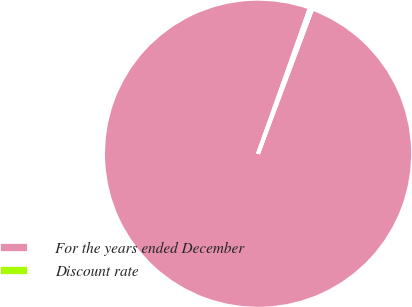Convert chart to OTSL. <chart><loc_0><loc_0><loc_500><loc_500><pie_chart><fcel>For the years ended December<fcel>Discount rate<nl><fcel>99.72%<fcel>0.28%<nl></chart> 